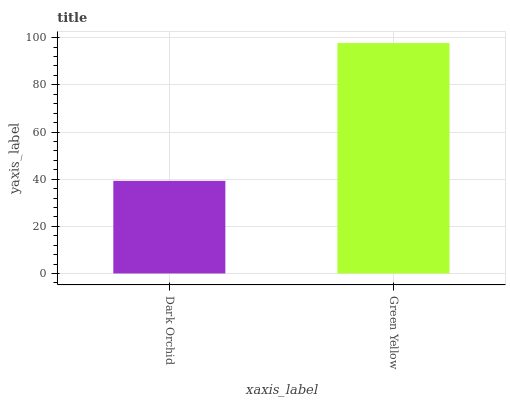Is Green Yellow the minimum?
Answer yes or no. No. Is Green Yellow greater than Dark Orchid?
Answer yes or no. Yes. Is Dark Orchid less than Green Yellow?
Answer yes or no. Yes. Is Dark Orchid greater than Green Yellow?
Answer yes or no. No. Is Green Yellow less than Dark Orchid?
Answer yes or no. No. Is Green Yellow the high median?
Answer yes or no. Yes. Is Dark Orchid the low median?
Answer yes or no. Yes. Is Dark Orchid the high median?
Answer yes or no. No. Is Green Yellow the low median?
Answer yes or no. No. 